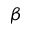<formula> <loc_0><loc_0><loc_500><loc_500>\beta</formula> 